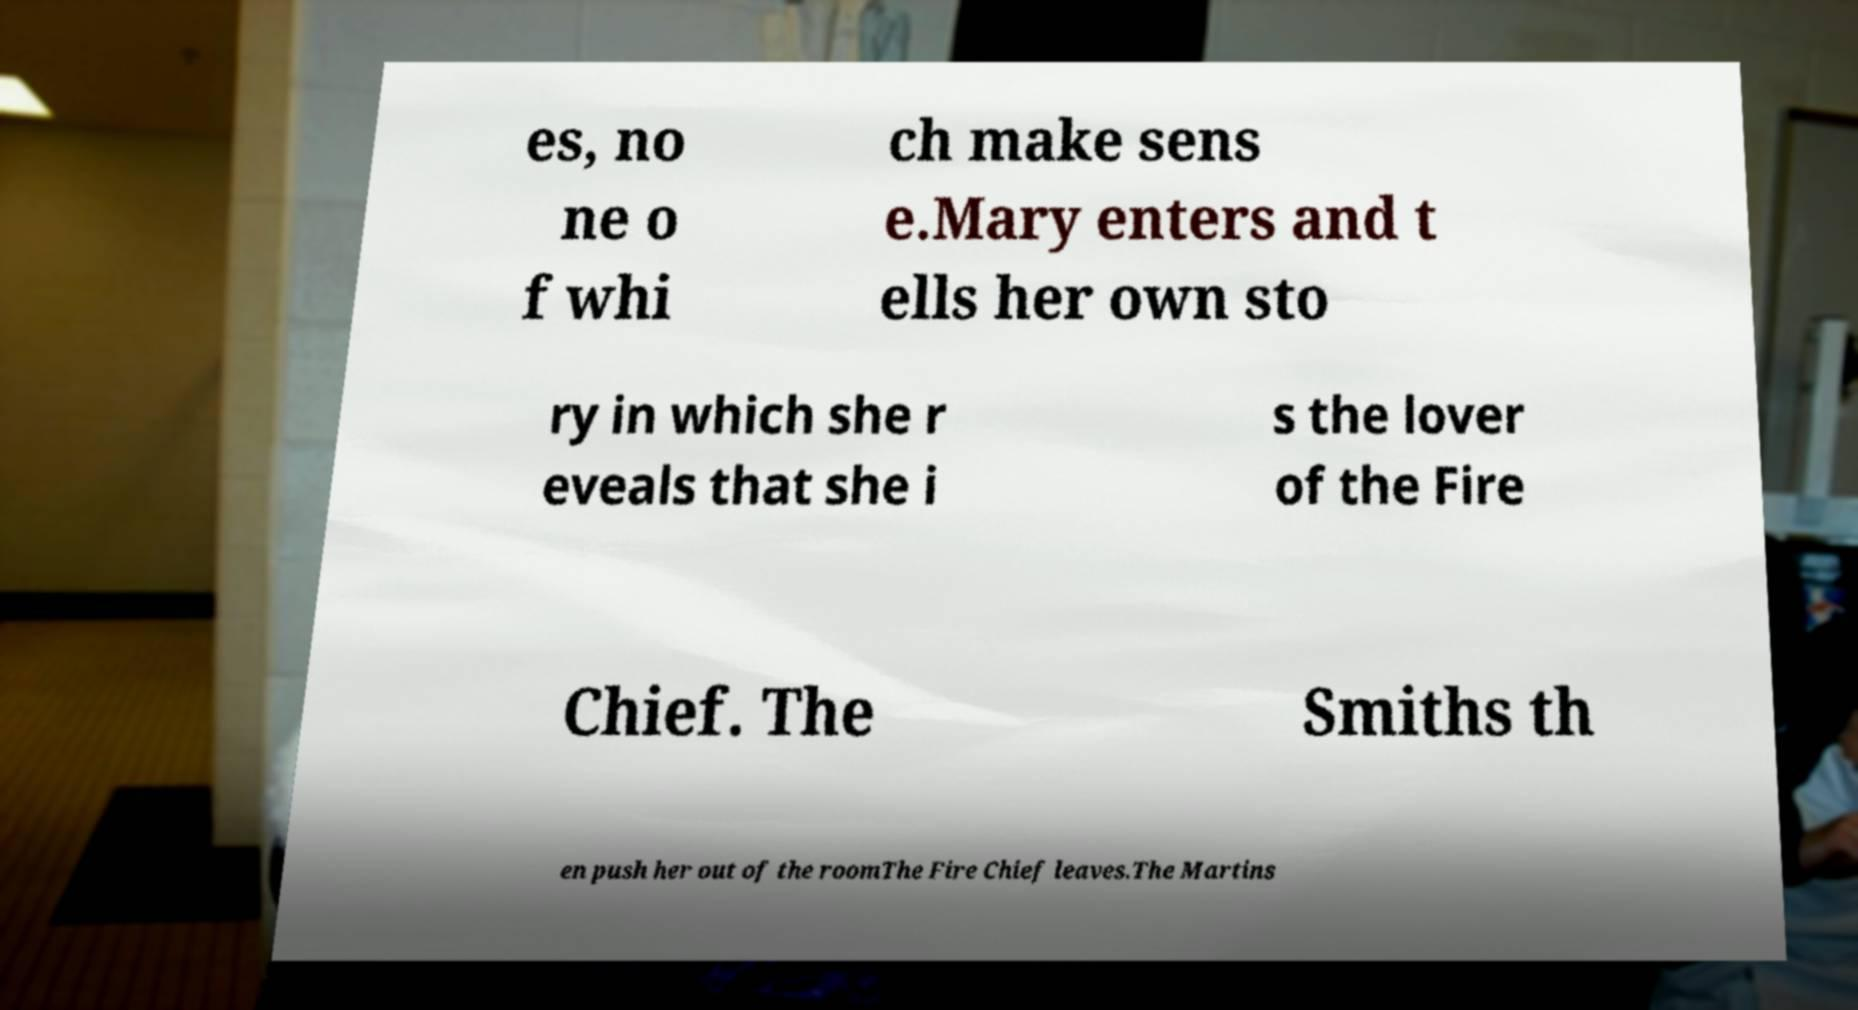Can you accurately transcribe the text from the provided image for me? es, no ne o f whi ch make sens e.Mary enters and t ells her own sto ry in which she r eveals that she i s the lover of the Fire Chief. The Smiths th en push her out of the roomThe Fire Chief leaves.The Martins 